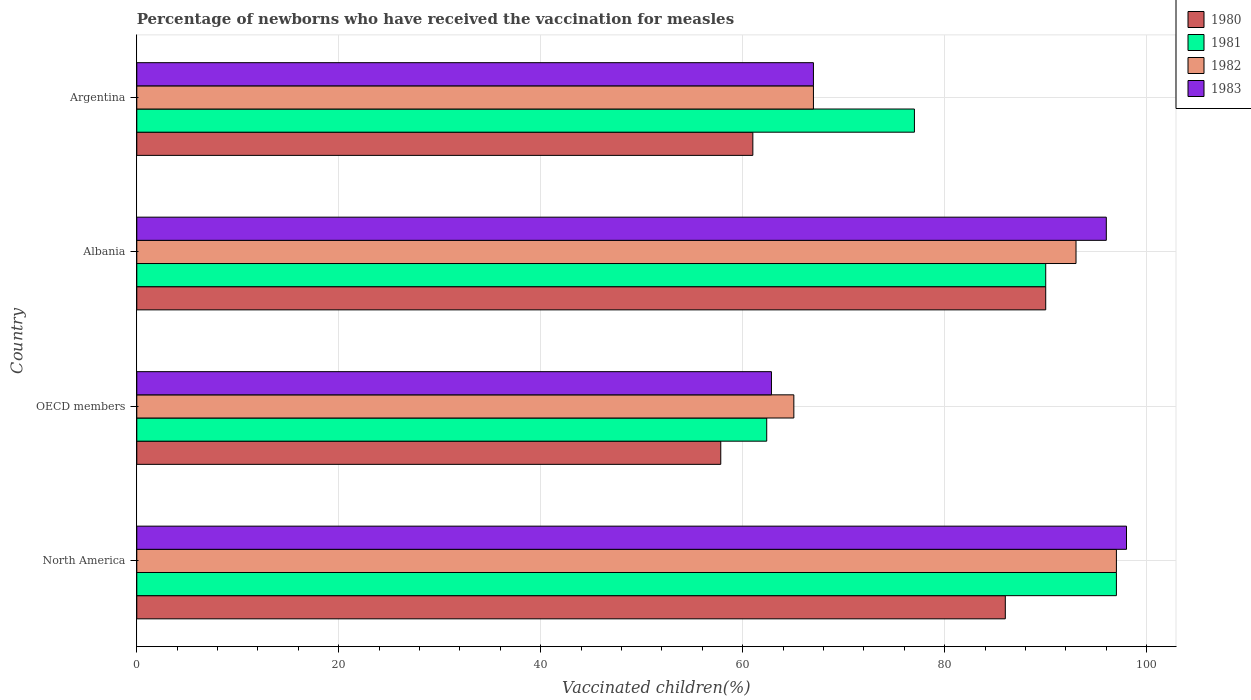How many different coloured bars are there?
Give a very brief answer. 4. Are the number of bars per tick equal to the number of legend labels?
Ensure brevity in your answer.  Yes. Are the number of bars on each tick of the Y-axis equal?
Your response must be concise. Yes. How many bars are there on the 1st tick from the top?
Your answer should be compact. 4. How many bars are there on the 4th tick from the bottom?
Keep it short and to the point. 4. In how many cases, is the number of bars for a given country not equal to the number of legend labels?
Keep it short and to the point. 0. What is the percentage of vaccinated children in 1982 in North America?
Keep it short and to the point. 97. Across all countries, what is the maximum percentage of vaccinated children in 1981?
Your answer should be very brief. 97. Across all countries, what is the minimum percentage of vaccinated children in 1980?
Provide a short and direct response. 57.82. In which country was the percentage of vaccinated children in 1981 maximum?
Your answer should be very brief. North America. What is the total percentage of vaccinated children in 1980 in the graph?
Provide a succinct answer. 294.82. What is the difference between the percentage of vaccinated children in 1980 in Albania and that in OECD members?
Make the answer very short. 32.18. What is the difference between the percentage of vaccinated children in 1982 in Argentina and the percentage of vaccinated children in 1980 in North America?
Ensure brevity in your answer.  -19. What is the average percentage of vaccinated children in 1980 per country?
Offer a terse response. 73.71. What is the difference between the percentage of vaccinated children in 1981 and percentage of vaccinated children in 1982 in North America?
Provide a succinct answer. 0. What is the ratio of the percentage of vaccinated children in 1980 in Argentina to that in North America?
Provide a short and direct response. 0.71. Is the percentage of vaccinated children in 1981 in Argentina less than that in North America?
Give a very brief answer. Yes. What is the difference between the highest and the second highest percentage of vaccinated children in 1983?
Your response must be concise. 2. What is the difference between the highest and the lowest percentage of vaccinated children in 1982?
Provide a short and direct response. 31.94. In how many countries, is the percentage of vaccinated children in 1981 greater than the average percentage of vaccinated children in 1981 taken over all countries?
Make the answer very short. 2. Is the sum of the percentage of vaccinated children in 1982 in Argentina and North America greater than the maximum percentage of vaccinated children in 1980 across all countries?
Offer a very short reply. Yes. What does the 3rd bar from the top in Albania represents?
Provide a short and direct response. 1981. Is it the case that in every country, the sum of the percentage of vaccinated children in 1980 and percentage of vaccinated children in 1982 is greater than the percentage of vaccinated children in 1983?
Your answer should be very brief. Yes. Are all the bars in the graph horizontal?
Your answer should be very brief. Yes. Are the values on the major ticks of X-axis written in scientific E-notation?
Provide a short and direct response. No. Does the graph contain grids?
Ensure brevity in your answer.  Yes. How many legend labels are there?
Keep it short and to the point. 4. What is the title of the graph?
Offer a very short reply. Percentage of newborns who have received the vaccination for measles. What is the label or title of the X-axis?
Provide a short and direct response. Vaccinated children(%). What is the label or title of the Y-axis?
Give a very brief answer. Country. What is the Vaccinated children(%) in 1981 in North America?
Give a very brief answer. 97. What is the Vaccinated children(%) in 1982 in North America?
Your answer should be very brief. 97. What is the Vaccinated children(%) in 1983 in North America?
Provide a short and direct response. 98. What is the Vaccinated children(%) of 1980 in OECD members?
Offer a very short reply. 57.82. What is the Vaccinated children(%) of 1981 in OECD members?
Offer a very short reply. 62.37. What is the Vaccinated children(%) of 1982 in OECD members?
Provide a succinct answer. 65.06. What is the Vaccinated children(%) of 1983 in OECD members?
Your answer should be compact. 62.84. What is the Vaccinated children(%) of 1980 in Albania?
Provide a short and direct response. 90. What is the Vaccinated children(%) in 1981 in Albania?
Your response must be concise. 90. What is the Vaccinated children(%) in 1982 in Albania?
Ensure brevity in your answer.  93. What is the Vaccinated children(%) in 1983 in Albania?
Make the answer very short. 96. What is the Vaccinated children(%) in 1980 in Argentina?
Ensure brevity in your answer.  61. What is the Vaccinated children(%) in 1981 in Argentina?
Offer a very short reply. 77. What is the Vaccinated children(%) of 1983 in Argentina?
Your answer should be very brief. 67. Across all countries, what is the maximum Vaccinated children(%) in 1980?
Make the answer very short. 90. Across all countries, what is the maximum Vaccinated children(%) in 1981?
Your answer should be very brief. 97. Across all countries, what is the maximum Vaccinated children(%) in 1982?
Make the answer very short. 97. Across all countries, what is the maximum Vaccinated children(%) of 1983?
Offer a terse response. 98. Across all countries, what is the minimum Vaccinated children(%) of 1980?
Ensure brevity in your answer.  57.82. Across all countries, what is the minimum Vaccinated children(%) of 1981?
Offer a very short reply. 62.37. Across all countries, what is the minimum Vaccinated children(%) of 1982?
Offer a terse response. 65.06. Across all countries, what is the minimum Vaccinated children(%) of 1983?
Your answer should be compact. 62.84. What is the total Vaccinated children(%) in 1980 in the graph?
Your response must be concise. 294.82. What is the total Vaccinated children(%) in 1981 in the graph?
Make the answer very short. 326.37. What is the total Vaccinated children(%) in 1982 in the graph?
Give a very brief answer. 322.06. What is the total Vaccinated children(%) of 1983 in the graph?
Your answer should be compact. 323.84. What is the difference between the Vaccinated children(%) in 1980 in North America and that in OECD members?
Make the answer very short. 28.18. What is the difference between the Vaccinated children(%) in 1981 in North America and that in OECD members?
Your response must be concise. 34.63. What is the difference between the Vaccinated children(%) of 1982 in North America and that in OECD members?
Make the answer very short. 31.94. What is the difference between the Vaccinated children(%) of 1983 in North America and that in OECD members?
Provide a succinct answer. 35.16. What is the difference between the Vaccinated children(%) of 1982 in North America and that in Albania?
Ensure brevity in your answer.  4. What is the difference between the Vaccinated children(%) in 1980 in OECD members and that in Albania?
Your answer should be compact. -32.18. What is the difference between the Vaccinated children(%) in 1981 in OECD members and that in Albania?
Provide a succinct answer. -27.63. What is the difference between the Vaccinated children(%) of 1982 in OECD members and that in Albania?
Your answer should be compact. -27.94. What is the difference between the Vaccinated children(%) in 1983 in OECD members and that in Albania?
Provide a short and direct response. -33.16. What is the difference between the Vaccinated children(%) in 1980 in OECD members and that in Argentina?
Your response must be concise. -3.18. What is the difference between the Vaccinated children(%) in 1981 in OECD members and that in Argentina?
Offer a terse response. -14.63. What is the difference between the Vaccinated children(%) of 1982 in OECD members and that in Argentina?
Offer a very short reply. -1.94. What is the difference between the Vaccinated children(%) in 1983 in OECD members and that in Argentina?
Make the answer very short. -4.16. What is the difference between the Vaccinated children(%) in 1980 in North America and the Vaccinated children(%) in 1981 in OECD members?
Offer a terse response. 23.63. What is the difference between the Vaccinated children(%) in 1980 in North America and the Vaccinated children(%) in 1982 in OECD members?
Give a very brief answer. 20.94. What is the difference between the Vaccinated children(%) in 1980 in North America and the Vaccinated children(%) in 1983 in OECD members?
Provide a short and direct response. 23.16. What is the difference between the Vaccinated children(%) in 1981 in North America and the Vaccinated children(%) in 1982 in OECD members?
Offer a very short reply. 31.94. What is the difference between the Vaccinated children(%) of 1981 in North America and the Vaccinated children(%) of 1983 in OECD members?
Ensure brevity in your answer.  34.16. What is the difference between the Vaccinated children(%) of 1982 in North America and the Vaccinated children(%) of 1983 in OECD members?
Offer a very short reply. 34.16. What is the difference between the Vaccinated children(%) in 1980 in North America and the Vaccinated children(%) in 1983 in Albania?
Give a very brief answer. -10. What is the difference between the Vaccinated children(%) of 1982 in North America and the Vaccinated children(%) of 1983 in Albania?
Give a very brief answer. 1. What is the difference between the Vaccinated children(%) of 1980 in North America and the Vaccinated children(%) of 1982 in Argentina?
Provide a short and direct response. 19. What is the difference between the Vaccinated children(%) of 1980 in North America and the Vaccinated children(%) of 1983 in Argentina?
Your answer should be very brief. 19. What is the difference between the Vaccinated children(%) of 1981 in North America and the Vaccinated children(%) of 1983 in Argentina?
Your answer should be very brief. 30. What is the difference between the Vaccinated children(%) of 1980 in OECD members and the Vaccinated children(%) of 1981 in Albania?
Provide a succinct answer. -32.18. What is the difference between the Vaccinated children(%) of 1980 in OECD members and the Vaccinated children(%) of 1982 in Albania?
Keep it short and to the point. -35.18. What is the difference between the Vaccinated children(%) in 1980 in OECD members and the Vaccinated children(%) in 1983 in Albania?
Give a very brief answer. -38.18. What is the difference between the Vaccinated children(%) of 1981 in OECD members and the Vaccinated children(%) of 1982 in Albania?
Make the answer very short. -30.63. What is the difference between the Vaccinated children(%) in 1981 in OECD members and the Vaccinated children(%) in 1983 in Albania?
Provide a short and direct response. -33.63. What is the difference between the Vaccinated children(%) of 1982 in OECD members and the Vaccinated children(%) of 1983 in Albania?
Keep it short and to the point. -30.94. What is the difference between the Vaccinated children(%) of 1980 in OECD members and the Vaccinated children(%) of 1981 in Argentina?
Provide a succinct answer. -19.18. What is the difference between the Vaccinated children(%) of 1980 in OECD members and the Vaccinated children(%) of 1982 in Argentina?
Offer a very short reply. -9.18. What is the difference between the Vaccinated children(%) in 1980 in OECD members and the Vaccinated children(%) in 1983 in Argentina?
Provide a succinct answer. -9.18. What is the difference between the Vaccinated children(%) of 1981 in OECD members and the Vaccinated children(%) of 1982 in Argentina?
Provide a succinct answer. -4.63. What is the difference between the Vaccinated children(%) of 1981 in OECD members and the Vaccinated children(%) of 1983 in Argentina?
Make the answer very short. -4.63. What is the difference between the Vaccinated children(%) in 1982 in OECD members and the Vaccinated children(%) in 1983 in Argentina?
Offer a very short reply. -1.94. What is the difference between the Vaccinated children(%) of 1981 in Albania and the Vaccinated children(%) of 1983 in Argentina?
Give a very brief answer. 23. What is the average Vaccinated children(%) in 1980 per country?
Ensure brevity in your answer.  73.71. What is the average Vaccinated children(%) of 1981 per country?
Offer a very short reply. 81.59. What is the average Vaccinated children(%) in 1982 per country?
Provide a short and direct response. 80.52. What is the average Vaccinated children(%) of 1983 per country?
Ensure brevity in your answer.  80.96. What is the difference between the Vaccinated children(%) in 1980 and Vaccinated children(%) in 1983 in North America?
Provide a succinct answer. -12. What is the difference between the Vaccinated children(%) of 1981 and Vaccinated children(%) of 1982 in North America?
Ensure brevity in your answer.  0. What is the difference between the Vaccinated children(%) in 1981 and Vaccinated children(%) in 1983 in North America?
Your answer should be very brief. -1. What is the difference between the Vaccinated children(%) in 1982 and Vaccinated children(%) in 1983 in North America?
Give a very brief answer. -1. What is the difference between the Vaccinated children(%) in 1980 and Vaccinated children(%) in 1981 in OECD members?
Your answer should be compact. -4.55. What is the difference between the Vaccinated children(%) of 1980 and Vaccinated children(%) of 1982 in OECD members?
Offer a very short reply. -7.24. What is the difference between the Vaccinated children(%) in 1980 and Vaccinated children(%) in 1983 in OECD members?
Your response must be concise. -5.02. What is the difference between the Vaccinated children(%) in 1981 and Vaccinated children(%) in 1982 in OECD members?
Give a very brief answer. -2.69. What is the difference between the Vaccinated children(%) in 1981 and Vaccinated children(%) in 1983 in OECD members?
Ensure brevity in your answer.  -0.47. What is the difference between the Vaccinated children(%) in 1982 and Vaccinated children(%) in 1983 in OECD members?
Give a very brief answer. 2.22. What is the difference between the Vaccinated children(%) of 1980 and Vaccinated children(%) of 1982 in Albania?
Your answer should be very brief. -3. What is the difference between the Vaccinated children(%) in 1980 and Vaccinated children(%) in 1983 in Albania?
Your answer should be compact. -6. What is the difference between the Vaccinated children(%) in 1982 and Vaccinated children(%) in 1983 in Albania?
Keep it short and to the point. -3. What is the difference between the Vaccinated children(%) in 1980 and Vaccinated children(%) in 1981 in Argentina?
Your answer should be very brief. -16. What is the difference between the Vaccinated children(%) of 1980 and Vaccinated children(%) of 1982 in Argentina?
Give a very brief answer. -6. What is the difference between the Vaccinated children(%) of 1980 and Vaccinated children(%) of 1983 in Argentina?
Offer a very short reply. -6. What is the difference between the Vaccinated children(%) in 1981 and Vaccinated children(%) in 1982 in Argentina?
Your answer should be compact. 10. What is the difference between the Vaccinated children(%) of 1982 and Vaccinated children(%) of 1983 in Argentina?
Provide a short and direct response. 0. What is the ratio of the Vaccinated children(%) of 1980 in North America to that in OECD members?
Your answer should be compact. 1.49. What is the ratio of the Vaccinated children(%) in 1981 in North America to that in OECD members?
Provide a succinct answer. 1.56. What is the ratio of the Vaccinated children(%) of 1982 in North America to that in OECD members?
Offer a terse response. 1.49. What is the ratio of the Vaccinated children(%) in 1983 in North America to that in OECD members?
Your answer should be compact. 1.56. What is the ratio of the Vaccinated children(%) in 1980 in North America to that in Albania?
Provide a succinct answer. 0.96. What is the ratio of the Vaccinated children(%) of 1981 in North America to that in Albania?
Provide a short and direct response. 1.08. What is the ratio of the Vaccinated children(%) in 1982 in North America to that in Albania?
Offer a very short reply. 1.04. What is the ratio of the Vaccinated children(%) in 1983 in North America to that in Albania?
Give a very brief answer. 1.02. What is the ratio of the Vaccinated children(%) of 1980 in North America to that in Argentina?
Your answer should be compact. 1.41. What is the ratio of the Vaccinated children(%) in 1981 in North America to that in Argentina?
Ensure brevity in your answer.  1.26. What is the ratio of the Vaccinated children(%) in 1982 in North America to that in Argentina?
Offer a very short reply. 1.45. What is the ratio of the Vaccinated children(%) in 1983 in North America to that in Argentina?
Provide a succinct answer. 1.46. What is the ratio of the Vaccinated children(%) in 1980 in OECD members to that in Albania?
Keep it short and to the point. 0.64. What is the ratio of the Vaccinated children(%) of 1981 in OECD members to that in Albania?
Ensure brevity in your answer.  0.69. What is the ratio of the Vaccinated children(%) of 1982 in OECD members to that in Albania?
Your answer should be very brief. 0.7. What is the ratio of the Vaccinated children(%) in 1983 in OECD members to that in Albania?
Your answer should be very brief. 0.65. What is the ratio of the Vaccinated children(%) of 1980 in OECD members to that in Argentina?
Give a very brief answer. 0.95. What is the ratio of the Vaccinated children(%) of 1981 in OECD members to that in Argentina?
Give a very brief answer. 0.81. What is the ratio of the Vaccinated children(%) in 1982 in OECD members to that in Argentina?
Provide a succinct answer. 0.97. What is the ratio of the Vaccinated children(%) in 1983 in OECD members to that in Argentina?
Your answer should be very brief. 0.94. What is the ratio of the Vaccinated children(%) in 1980 in Albania to that in Argentina?
Your answer should be very brief. 1.48. What is the ratio of the Vaccinated children(%) in 1981 in Albania to that in Argentina?
Provide a succinct answer. 1.17. What is the ratio of the Vaccinated children(%) of 1982 in Albania to that in Argentina?
Ensure brevity in your answer.  1.39. What is the ratio of the Vaccinated children(%) in 1983 in Albania to that in Argentina?
Offer a very short reply. 1.43. What is the difference between the highest and the second highest Vaccinated children(%) of 1980?
Ensure brevity in your answer.  4. What is the difference between the highest and the second highest Vaccinated children(%) of 1981?
Your response must be concise. 7. What is the difference between the highest and the second highest Vaccinated children(%) of 1983?
Your response must be concise. 2. What is the difference between the highest and the lowest Vaccinated children(%) in 1980?
Ensure brevity in your answer.  32.18. What is the difference between the highest and the lowest Vaccinated children(%) of 1981?
Make the answer very short. 34.63. What is the difference between the highest and the lowest Vaccinated children(%) in 1982?
Make the answer very short. 31.94. What is the difference between the highest and the lowest Vaccinated children(%) in 1983?
Make the answer very short. 35.16. 